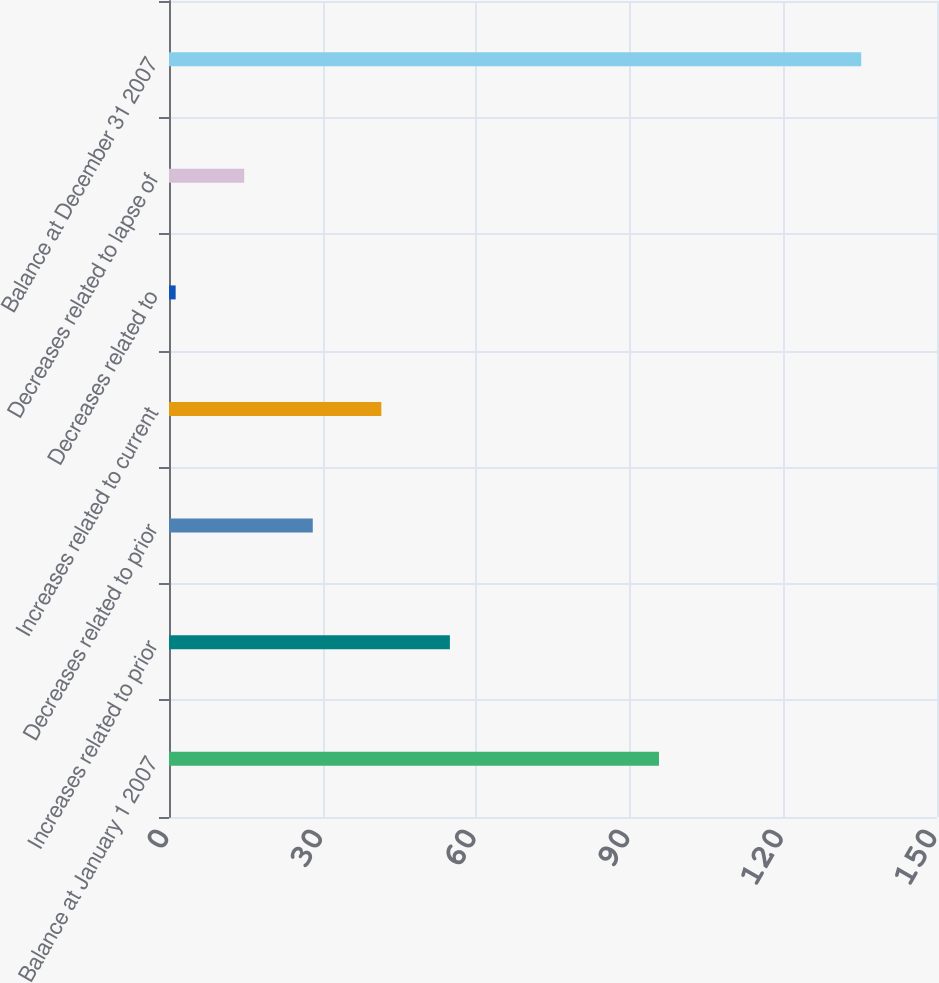Convert chart. <chart><loc_0><loc_0><loc_500><loc_500><bar_chart><fcel>Balance at January 1 2007<fcel>Increases related to prior<fcel>Decreases related to prior<fcel>Increases related to current<fcel>Decreases related to<fcel>Decreases related to lapse of<fcel>Balance at December 31 2007<nl><fcel>95.7<fcel>54.86<fcel>28.08<fcel>41.47<fcel>1.3<fcel>14.69<fcel>135.2<nl></chart> 